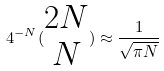<formula> <loc_0><loc_0><loc_500><loc_500>4 ^ { - N } ( \begin{matrix} 2 N \\ N \end{matrix} ) \approx \frac { 1 } { \sqrt { \pi N } }</formula> 